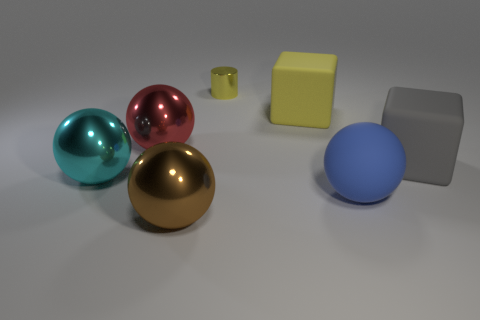There is a object that is both right of the yellow block and in front of the big cyan metal object; what is its shape?
Offer a very short reply. Sphere. How many cylinders have the same material as the large brown ball?
Your answer should be very brief. 1. Is the number of cyan metallic objects in front of the brown ball less than the number of things to the right of the gray matte cube?
Make the answer very short. No. The block on the left side of the block right of the large ball on the right side of the small cylinder is made of what material?
Provide a short and direct response. Rubber. How big is the object that is on the left side of the yellow block and on the right side of the large brown metal thing?
Make the answer very short. Small. How many cylinders are large gray shiny objects or small metallic objects?
Ensure brevity in your answer.  1. What color is the matte ball that is the same size as the brown thing?
Your answer should be compact. Blue. Are there any other things that have the same shape as the tiny yellow object?
Ensure brevity in your answer.  No. What is the color of the big rubber object that is the same shape as the red metal thing?
Make the answer very short. Blue. How many objects are either red spheres or big things to the right of the brown metal ball?
Offer a terse response. 4. 